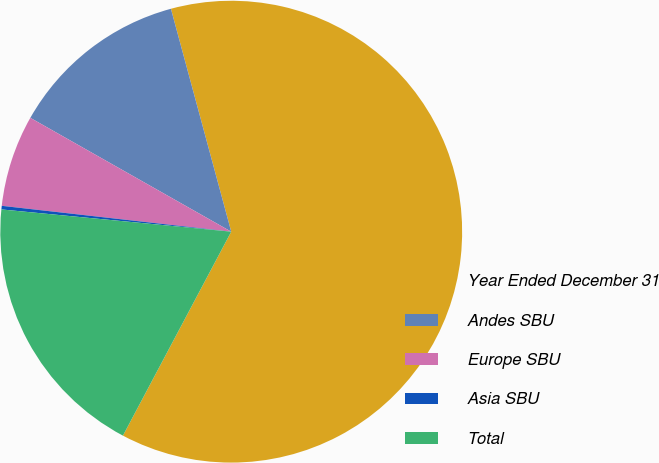<chart> <loc_0><loc_0><loc_500><loc_500><pie_chart><fcel>Year Ended December 31<fcel>Andes SBU<fcel>Europe SBU<fcel>Asia SBU<fcel>Total<nl><fcel>61.98%<fcel>12.59%<fcel>6.42%<fcel>0.25%<fcel>18.77%<nl></chart> 